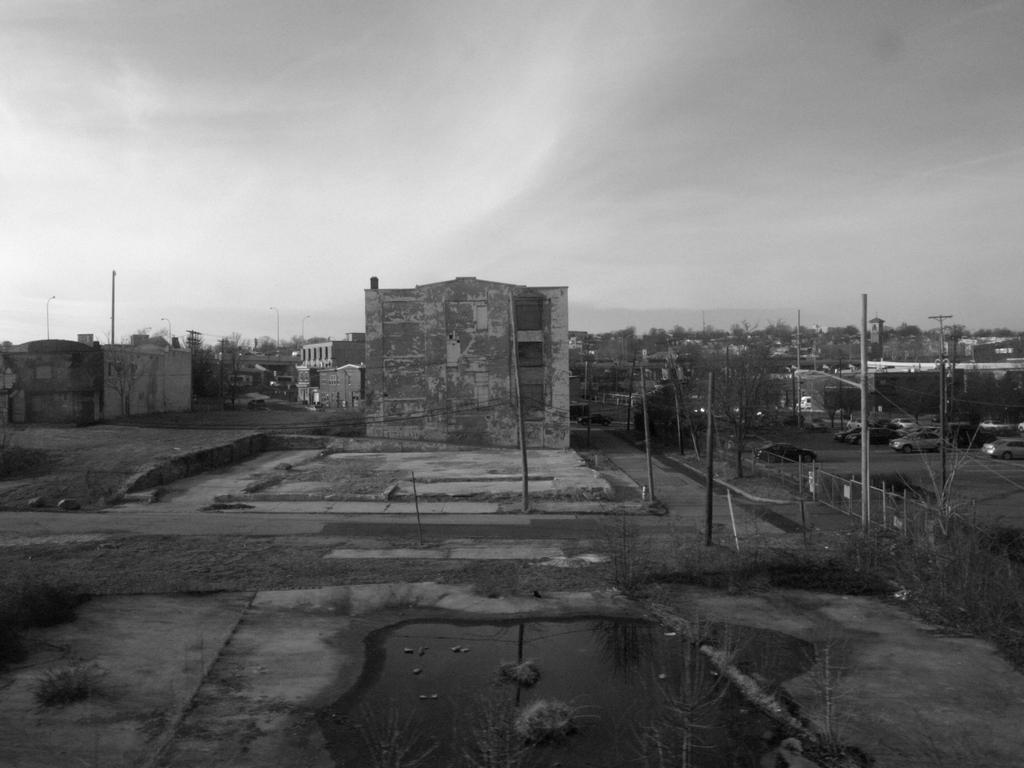What type of structures can be seen in the image? There are houses in the image. Are there any other objects or features visible in the image? Yes, there are electric poles in the image. What type of foot can be seen on the roof of the houses in the image? There are no feet visible on the roofs of the houses in the image. Is there a church present in the image? There is no mention of a church in the provided facts, and therefore it cannot be confirmed or denied. 